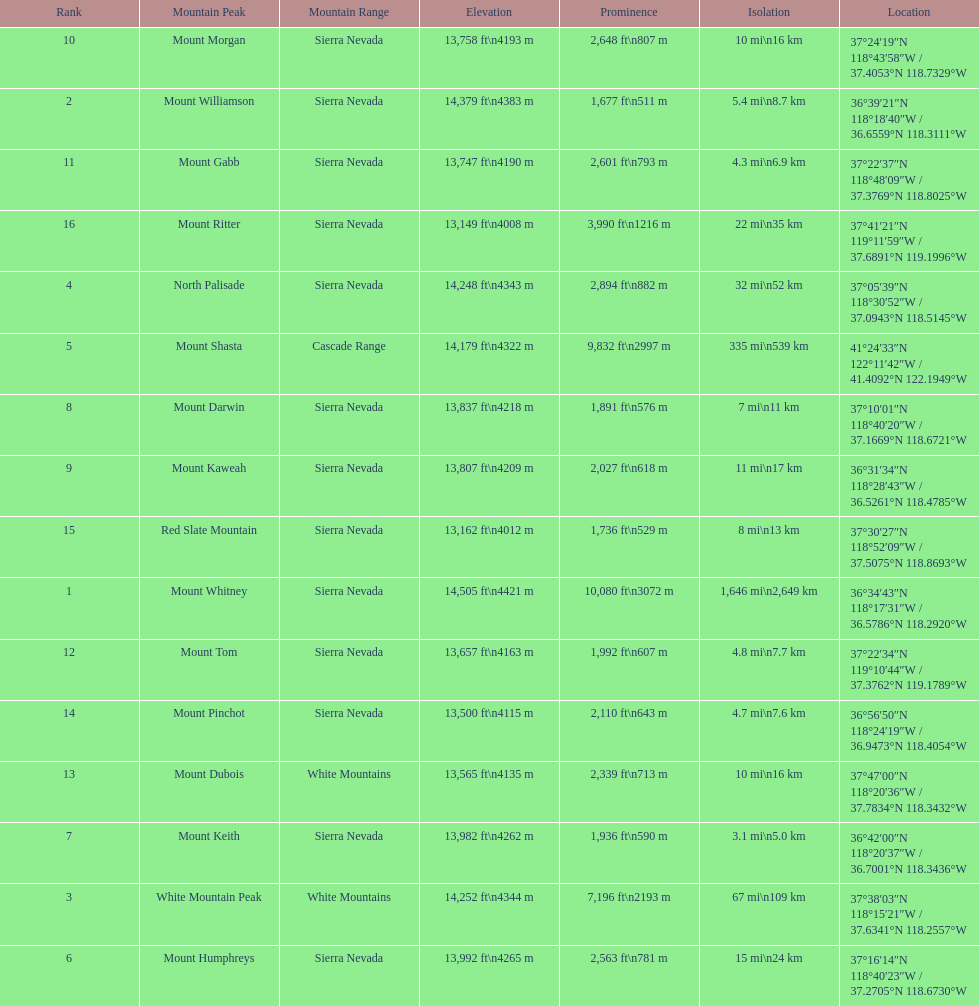What is the tallest peak in the sierra nevadas? Mount Whitney. 